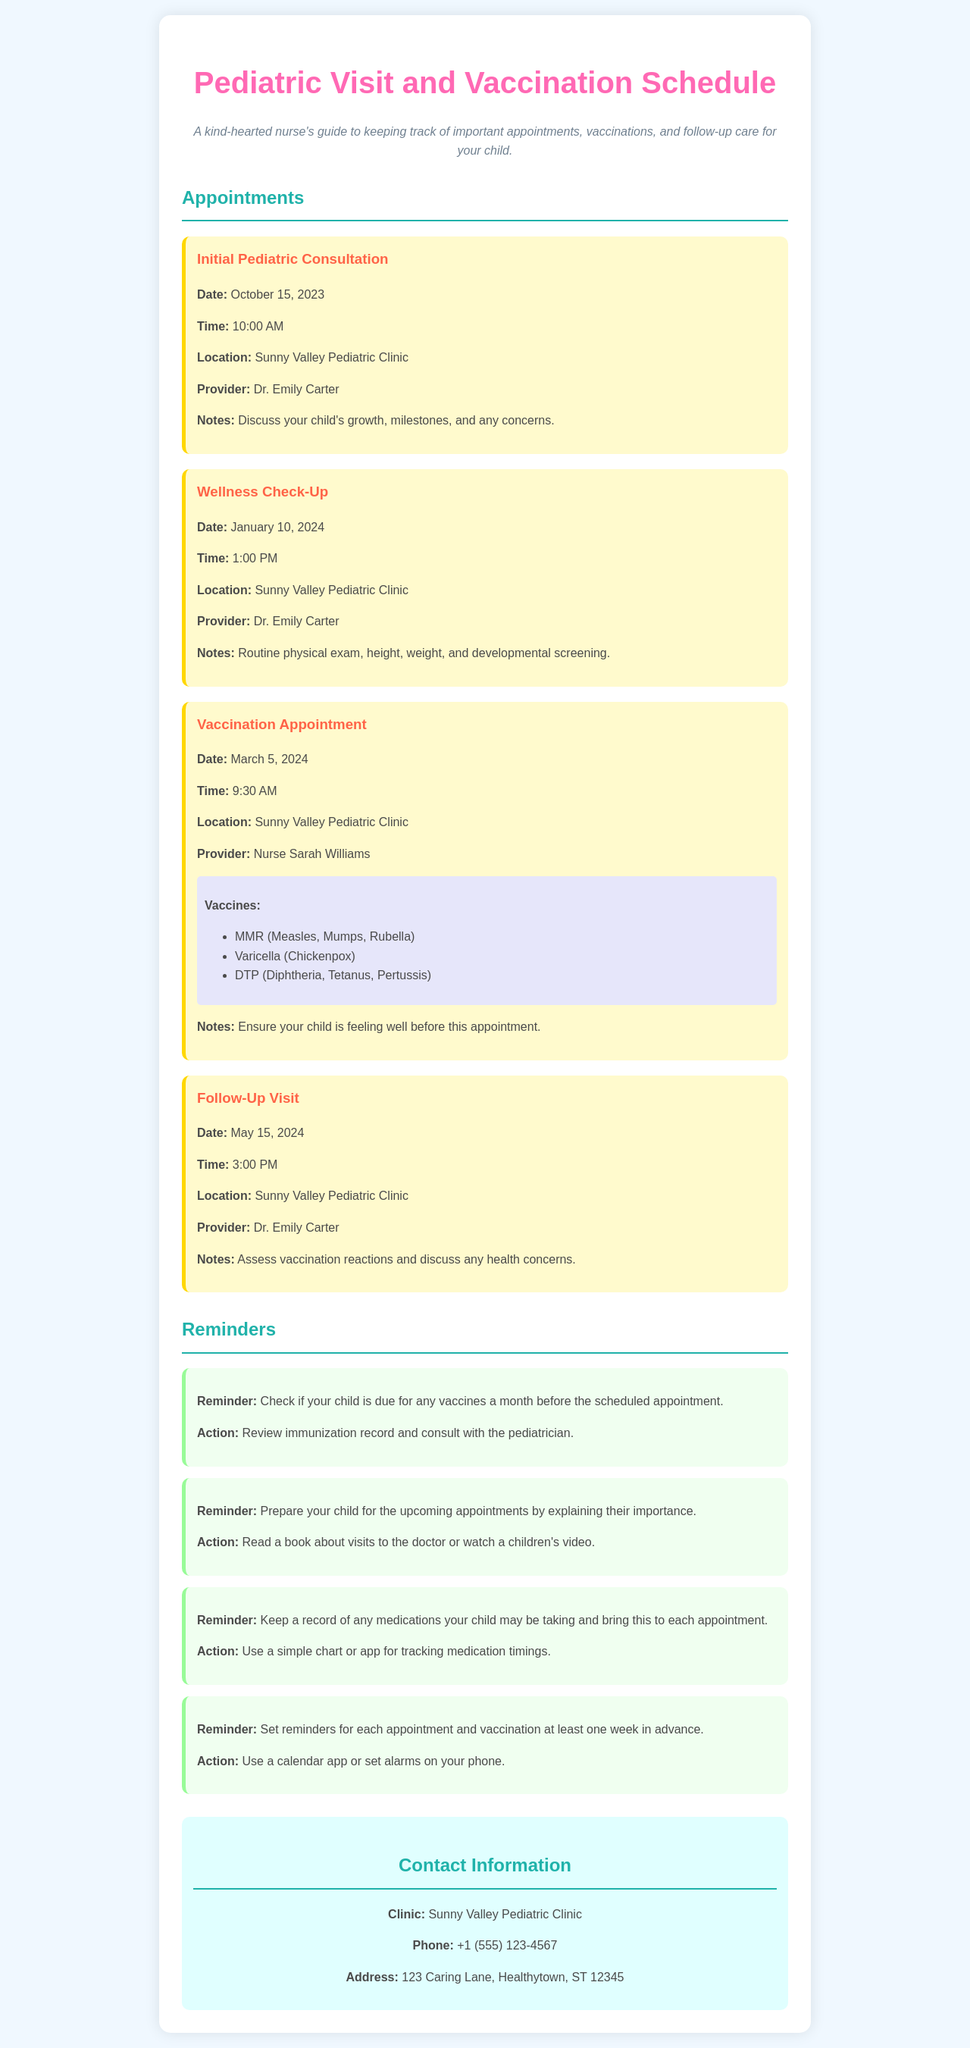what is the date of the initial pediatric consultation? The date is provided in the document under the "Initial Pediatric Consultation" section.
Answer: October 15, 2023 who is the provider for the wellness check-up? The provider's name is listed in the appointment details for the wellness check-up.
Answer: Dr. Emily Carter what vaccines are scheduled for the vaccination appointment? The vaccines are listed in the "Vaccination Appointment" section of the document.
Answer: MMR, Varicella, DTP what time is the follow-up visit? The appointment time is mentioned in the "Follow-Up Visit" section of the document.
Answer: 3:00 PM how far in advance should reminders be set for appointments? This information is provided in the "Reminders" section where the action for setting reminders is discussed.
Answer: One week what location is common for all appointments? The location is repeated in each appointment section and is key information throughout the document.
Answer: Sunny Valley Pediatric Clinic what should be reviewed before the vaccination appointment? This is specified in the notes for the vaccination appointment, which outlines what to ensure.
Answer: Child is feeling well which nurse is responsible for the vaccination appointment? The nurse's name is given in the vaccination appointment details.
Answer: Nurse Sarah Williams 